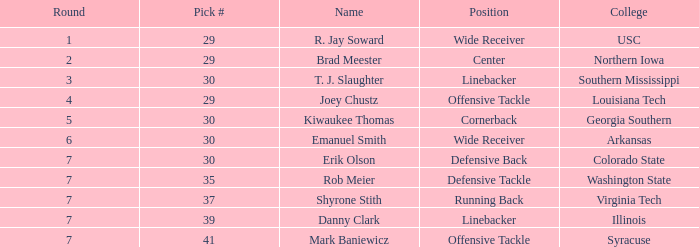What is the smallest round with a sum of 247 and a choice below 41? None. 